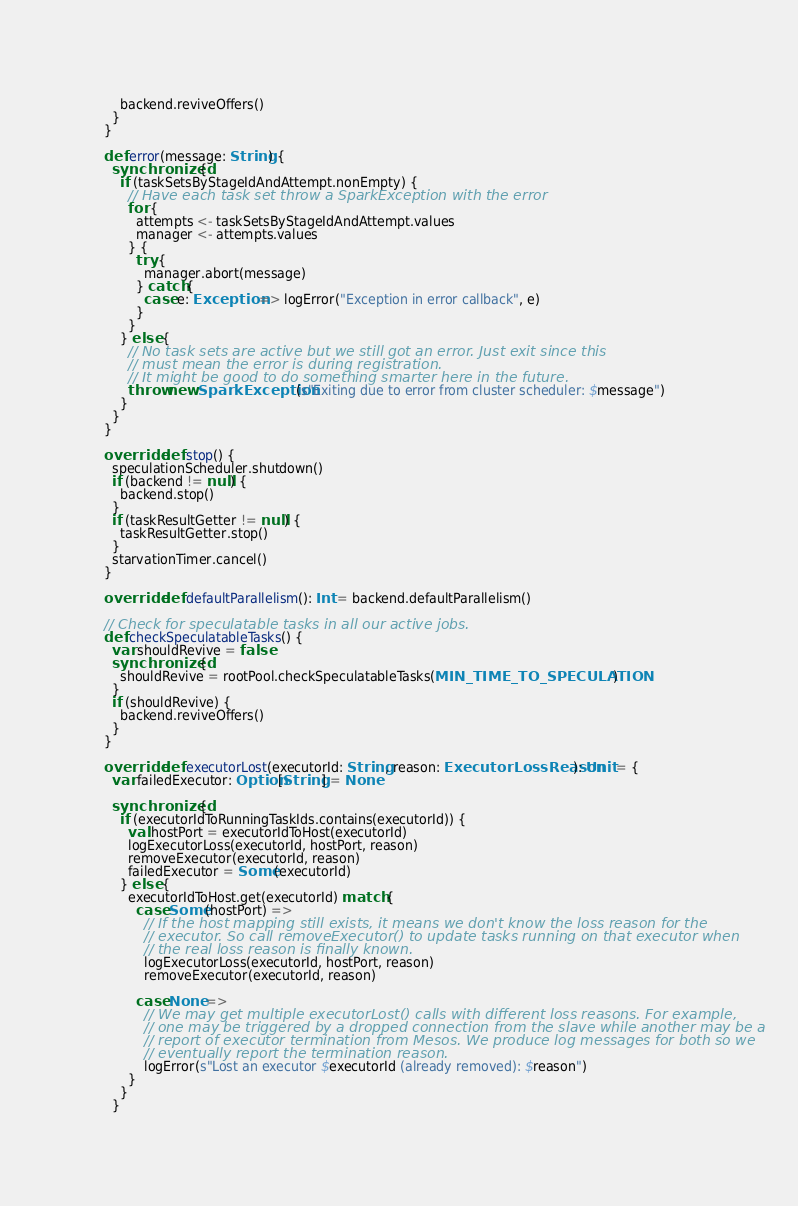Convert code to text. <code><loc_0><loc_0><loc_500><loc_500><_Scala_>      backend.reviveOffers()
    }
  }

  def error(message: String) {
    synchronized {
      if (taskSetsByStageIdAndAttempt.nonEmpty) {
        // Have each task set throw a SparkException with the error
        for {
          attempts <- taskSetsByStageIdAndAttempt.values
          manager <- attempts.values
        } {
          try {
            manager.abort(message)
          } catch {
            case e: Exception => logError("Exception in error callback", e)
          }
        }
      } else {
        // No task sets are active but we still got an error. Just exit since this
        // must mean the error is during registration.
        // It might be good to do something smarter here in the future.
        throw new SparkException(s"Exiting due to error from cluster scheduler: $message")
      }
    }
  }

  override def stop() {
    speculationScheduler.shutdown()
    if (backend != null) {
      backend.stop()
    }
    if (taskResultGetter != null) {
      taskResultGetter.stop()
    }
    starvationTimer.cancel()
  }

  override def defaultParallelism(): Int = backend.defaultParallelism()

  // Check for speculatable tasks in all our active jobs.
  def checkSpeculatableTasks() {
    var shouldRevive = false
    synchronized {
      shouldRevive = rootPool.checkSpeculatableTasks(MIN_TIME_TO_SPECULATION)
    }
    if (shouldRevive) {
      backend.reviveOffers()
    }
  }

  override def executorLost(executorId: String, reason: ExecutorLossReason): Unit = {
    var failedExecutor: Option[String] = None

    synchronized {
      if (executorIdToRunningTaskIds.contains(executorId)) {
        val hostPort = executorIdToHost(executorId)
        logExecutorLoss(executorId, hostPort, reason)
        removeExecutor(executorId, reason)
        failedExecutor = Some(executorId)
      } else {
        executorIdToHost.get(executorId) match {
          case Some(hostPort) =>
            // If the host mapping still exists, it means we don't know the loss reason for the
            // executor. So call removeExecutor() to update tasks running on that executor when
            // the real loss reason is finally known.
            logExecutorLoss(executorId, hostPort, reason)
            removeExecutor(executorId, reason)

          case None =>
            // We may get multiple executorLost() calls with different loss reasons. For example,
            // one may be triggered by a dropped connection from the slave while another may be a
            // report of executor termination from Mesos. We produce log messages for both so we
            // eventually report the termination reason.
            logError(s"Lost an executor $executorId (already removed): $reason")
        }
      }
    }</code> 